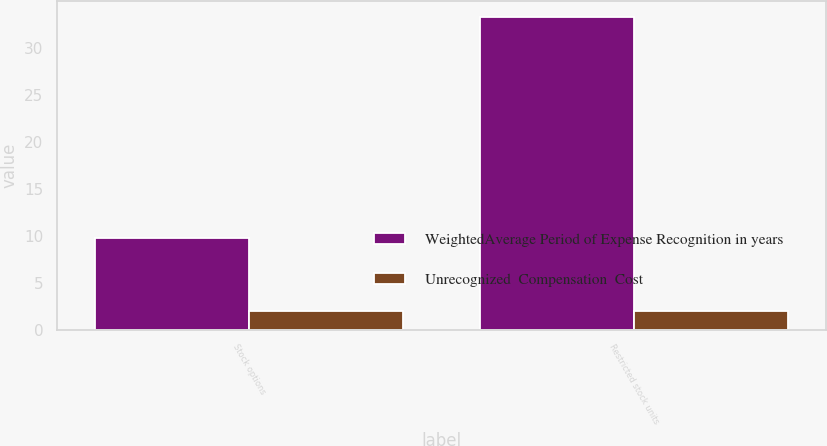Convert chart. <chart><loc_0><loc_0><loc_500><loc_500><stacked_bar_chart><ecel><fcel>Stock options<fcel>Restricted stock units<nl><fcel>WeightedAverage Period of Expense Recognition in years<fcel>9.7<fcel>33.3<nl><fcel>Unrecognized  Compensation  Cost<fcel>2<fcel>2<nl></chart> 